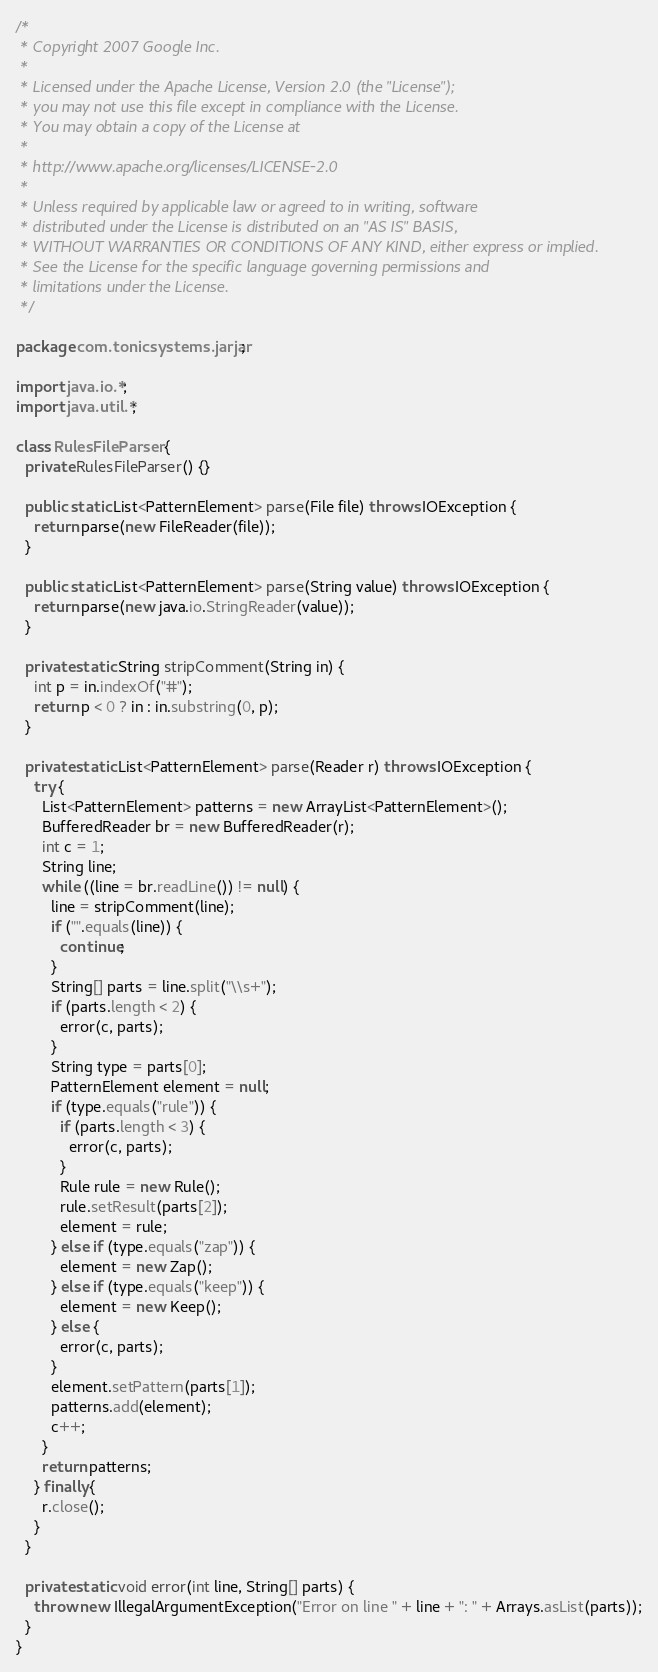<code> <loc_0><loc_0><loc_500><loc_500><_Java_>/*
 * Copyright 2007 Google Inc.
 *
 * Licensed under the Apache License, Version 2.0 (the "License");
 * you may not use this file except in compliance with the License.
 * You may obtain a copy of the License at
 *
 * http://www.apache.org/licenses/LICENSE-2.0
 *
 * Unless required by applicable law or agreed to in writing, software
 * distributed under the License is distributed on an "AS IS" BASIS,
 * WITHOUT WARRANTIES OR CONDITIONS OF ANY KIND, either express or implied.
 * See the License for the specific language governing permissions and
 * limitations under the License.
 */

package com.tonicsystems.jarjar;

import java.io.*;
import java.util.*;

class RulesFileParser {
  private RulesFileParser() {}

  public static List<PatternElement> parse(File file) throws IOException {
    return parse(new FileReader(file));
  }

  public static List<PatternElement> parse(String value) throws IOException {
    return parse(new java.io.StringReader(value));
  }

  private static String stripComment(String in) {
    int p = in.indexOf("#");
    return p < 0 ? in : in.substring(0, p);
  }

  private static List<PatternElement> parse(Reader r) throws IOException {
    try {
      List<PatternElement> patterns = new ArrayList<PatternElement>();
      BufferedReader br = new BufferedReader(r);
      int c = 1;
      String line;
      while ((line = br.readLine()) != null) {
        line = stripComment(line);
        if ("".equals(line)) {
          continue;
        }
        String[] parts = line.split("\\s+");
        if (parts.length < 2) {
          error(c, parts);
        }
        String type = parts[0];
        PatternElement element = null;
        if (type.equals("rule")) {
          if (parts.length < 3) {
            error(c, parts);
          }
          Rule rule = new Rule();
          rule.setResult(parts[2]);
          element = rule;
        } else if (type.equals("zap")) {
          element = new Zap();
        } else if (type.equals("keep")) {
          element = new Keep();
        } else {
          error(c, parts);
        }
        element.setPattern(parts[1]);
        patterns.add(element);
        c++;
      }
      return patterns;
    } finally {
      r.close();
    }
  }

  private static void error(int line, String[] parts) {
    throw new IllegalArgumentException("Error on line " + line + ": " + Arrays.asList(parts));
  }
}
</code> 